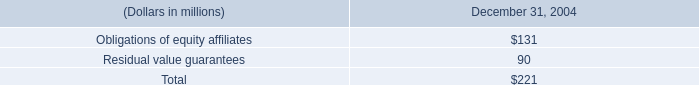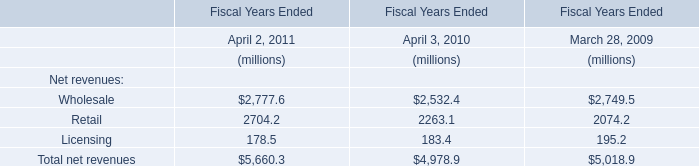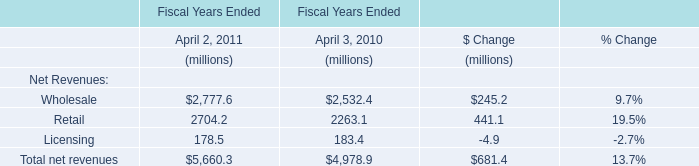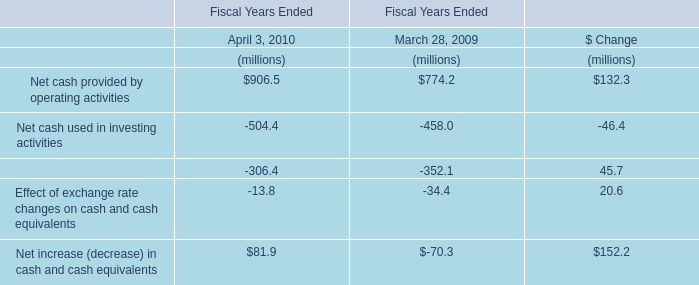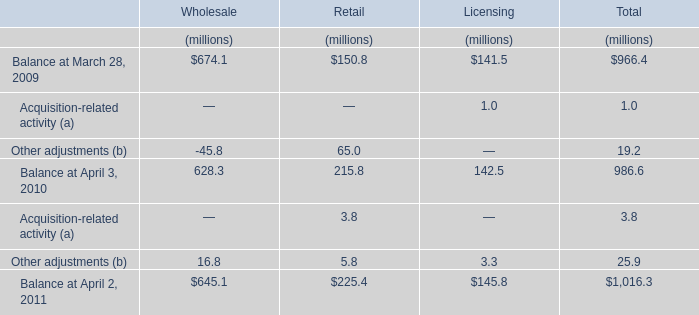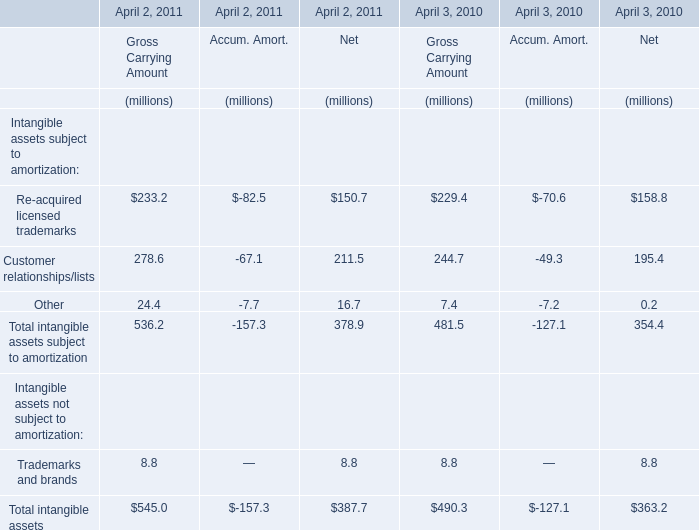What is the sum of Balance at March 28, 2009 in the range of1 and 1000 in 2009 ? (in million) 
Computations: (((674.1 + 150.8) + 141.5) + 966.4)
Answer: 1932.8. 